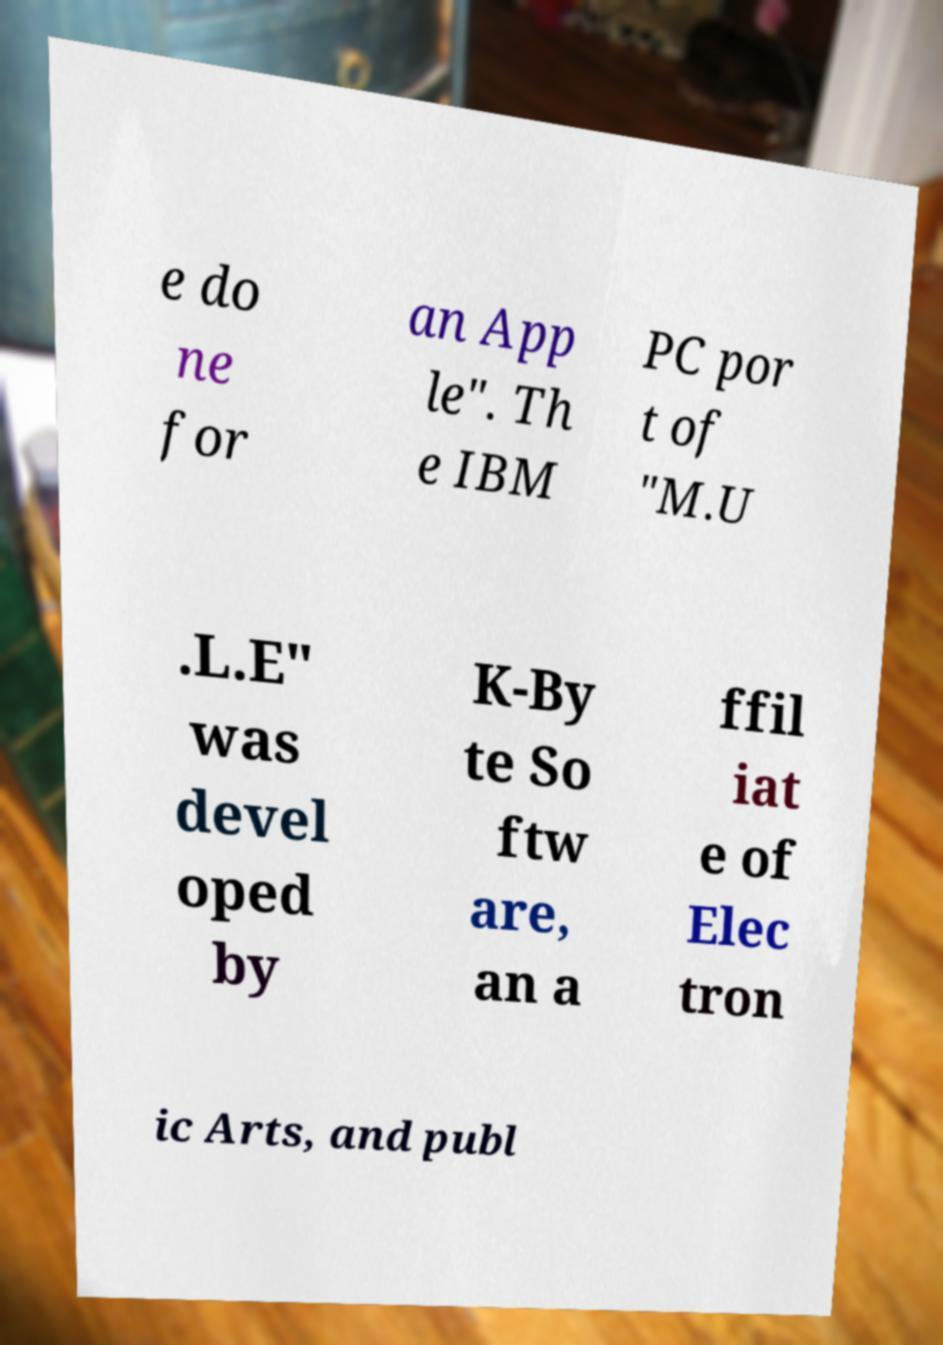There's text embedded in this image that I need extracted. Can you transcribe it verbatim? e do ne for an App le". Th e IBM PC por t of "M.U .L.E" was devel oped by K-By te So ftw are, an a ffil iat e of Elec tron ic Arts, and publ 